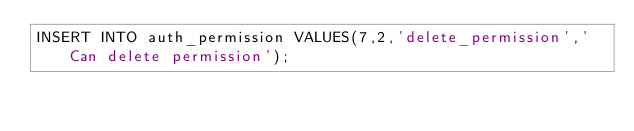Convert code to text. <code><loc_0><loc_0><loc_500><loc_500><_SQL_>INSERT INTO auth_permission VALUES(7,2,'delete_permission','Can delete permission');</code> 